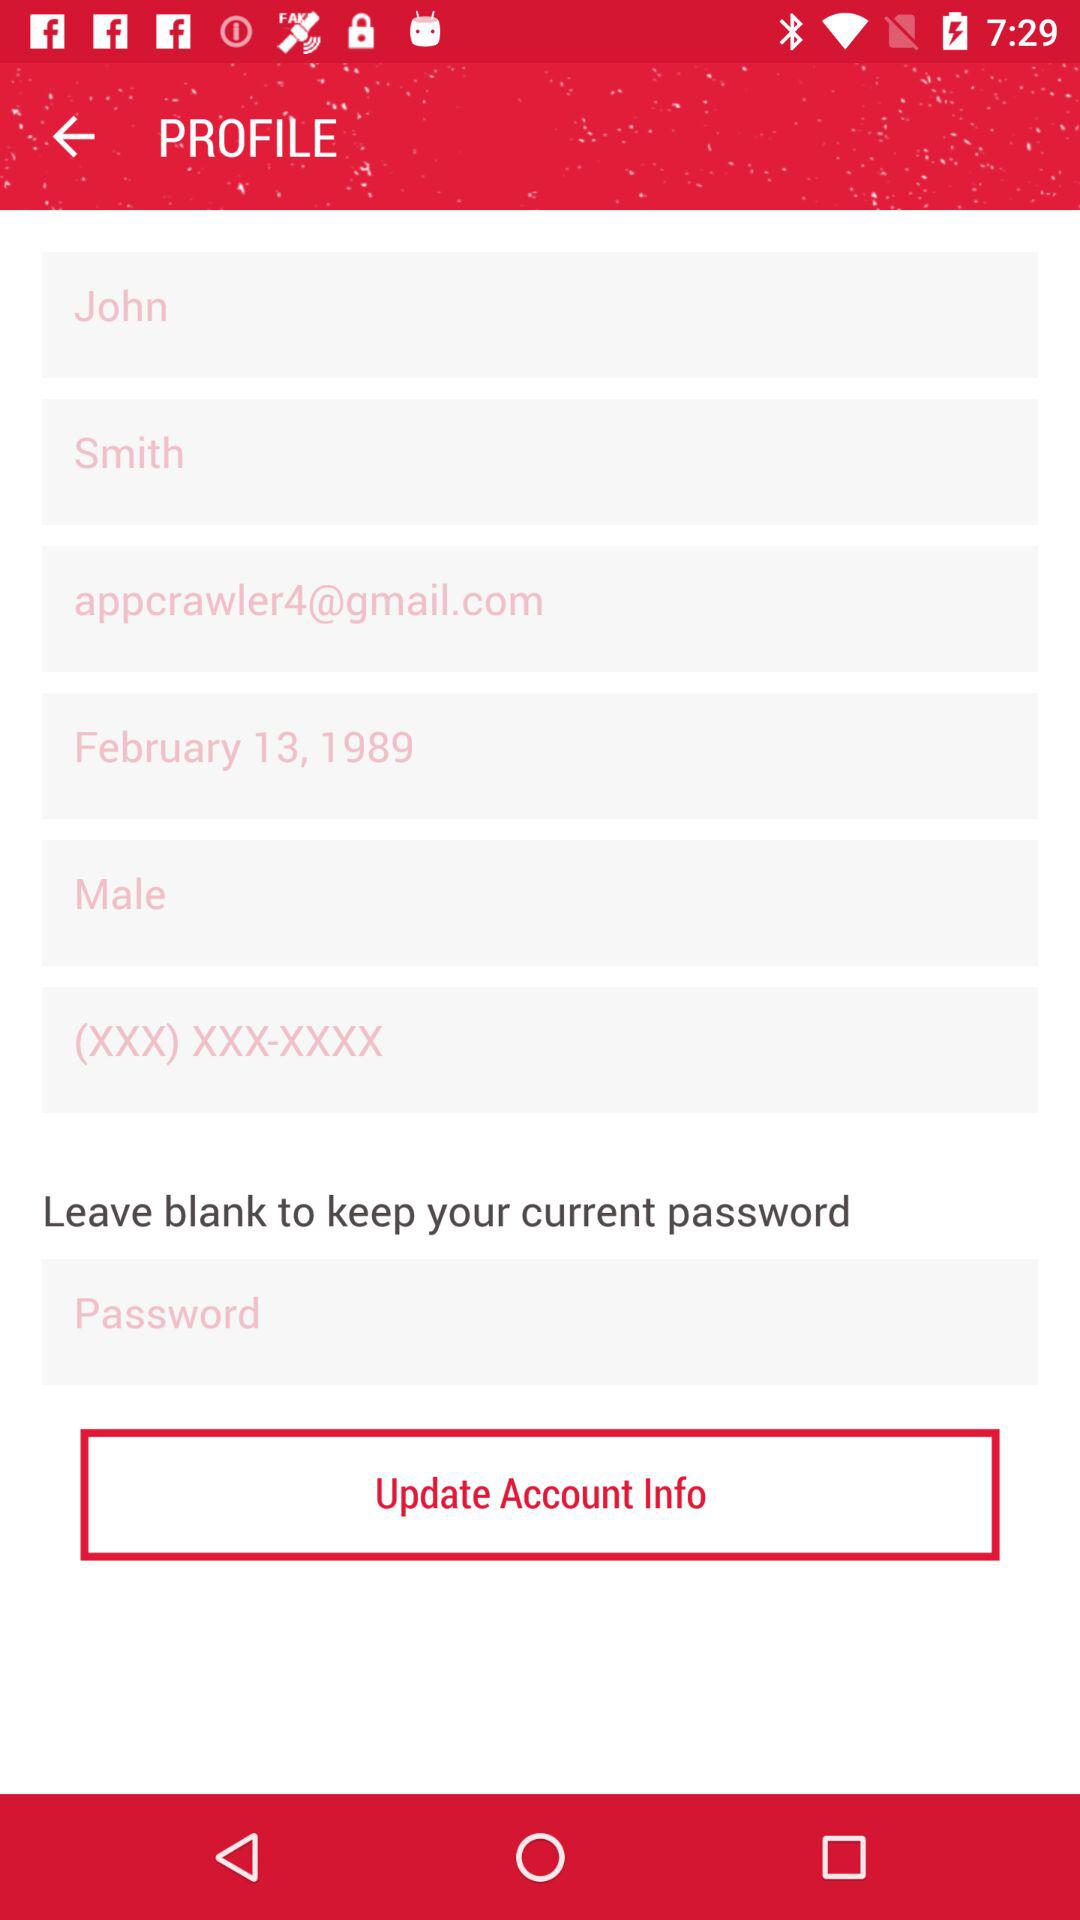Is the individual male or female? The individual is male. 